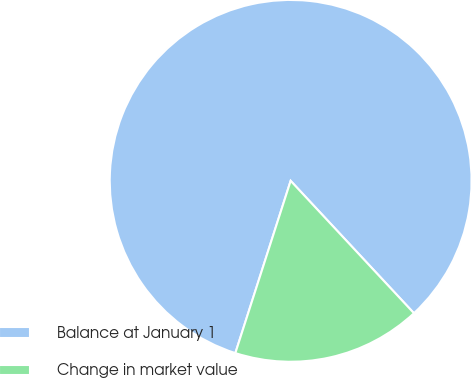Convert chart. <chart><loc_0><loc_0><loc_500><loc_500><pie_chart><fcel>Balance at January 1<fcel>Change in market value<nl><fcel>83.12%<fcel>16.88%<nl></chart> 